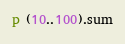<code> <loc_0><loc_0><loc_500><loc_500><_Ruby_>p (10..100).sum</code> 